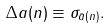Convert formula to latex. <formula><loc_0><loc_0><loc_500><loc_500>\Delta a ( n ) \equiv \sigma _ { \bar { a } ( n ) } .</formula> 